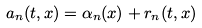Convert formula to latex. <formula><loc_0><loc_0><loc_500><loc_500>a _ { n } ( t , x ) = \alpha _ { n } ( x ) + r _ { n } ( t , x )</formula> 